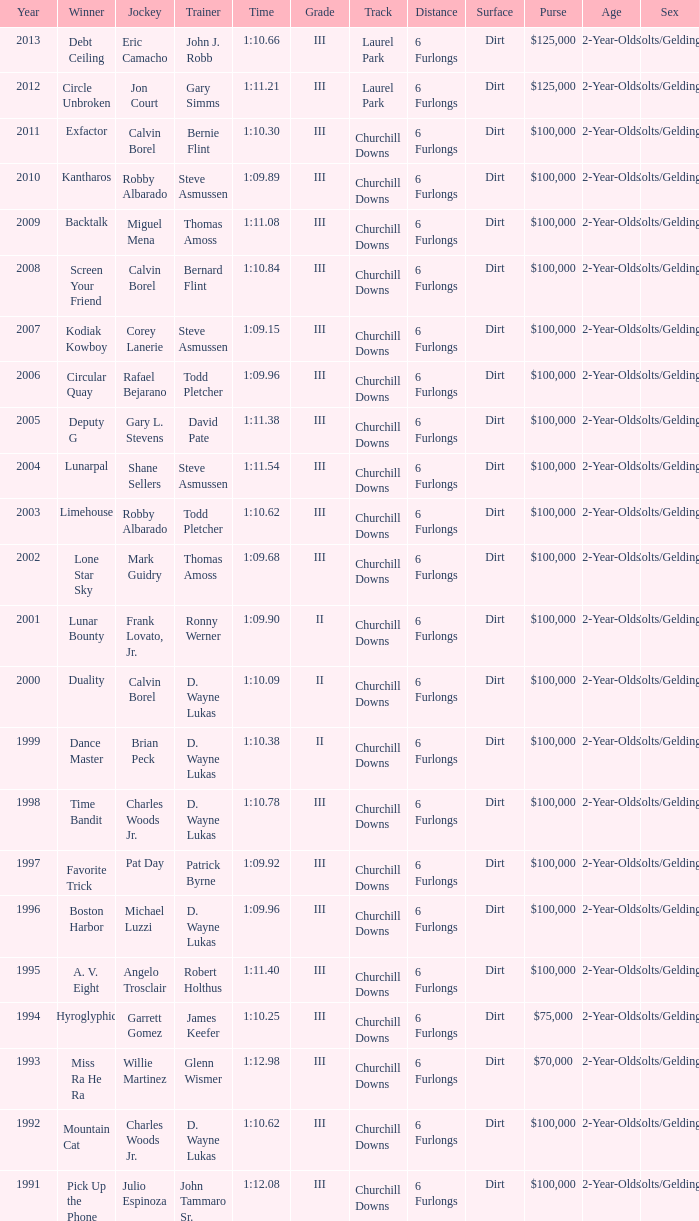Who achieved victory under gary simms' leadership? Circle Unbroken. 